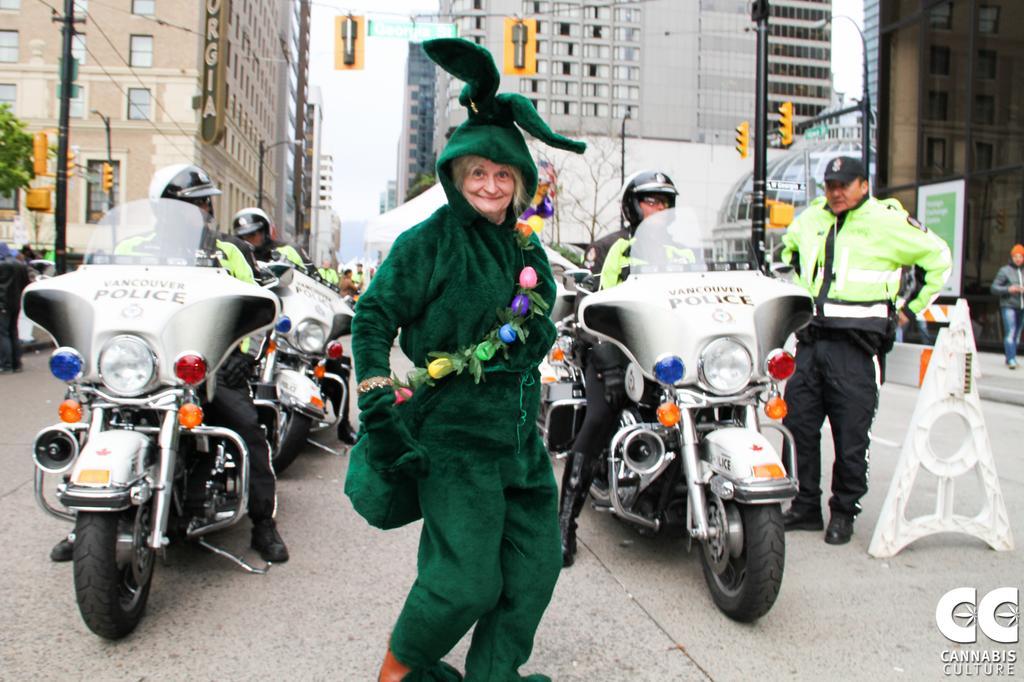Could you give a brief overview of what you see in this image? There is a woman standing at the center. There is a man on the bicycle. He is into the right side as well as left side. In the background there is a building and a traffic signal pole. 